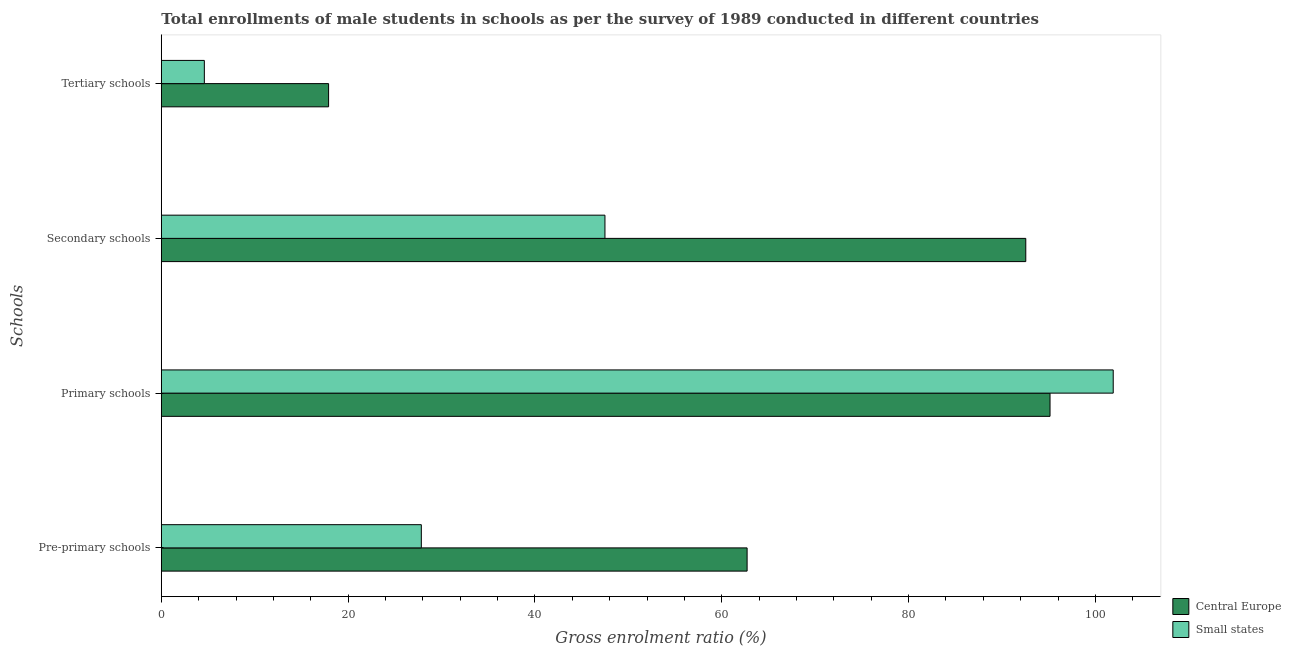How many different coloured bars are there?
Ensure brevity in your answer.  2. How many groups of bars are there?
Keep it short and to the point. 4. Are the number of bars per tick equal to the number of legend labels?
Your answer should be compact. Yes. Are the number of bars on each tick of the Y-axis equal?
Give a very brief answer. Yes. What is the label of the 2nd group of bars from the top?
Provide a short and direct response. Secondary schools. What is the gross enrolment ratio(male) in primary schools in Central Europe?
Your answer should be very brief. 95.15. Across all countries, what is the maximum gross enrolment ratio(male) in primary schools?
Provide a succinct answer. 101.91. Across all countries, what is the minimum gross enrolment ratio(male) in pre-primary schools?
Make the answer very short. 27.84. In which country was the gross enrolment ratio(male) in tertiary schools maximum?
Your response must be concise. Central Europe. In which country was the gross enrolment ratio(male) in primary schools minimum?
Provide a short and direct response. Central Europe. What is the total gross enrolment ratio(male) in pre-primary schools in the graph?
Give a very brief answer. 90.55. What is the difference between the gross enrolment ratio(male) in pre-primary schools in Small states and that in Central Europe?
Provide a short and direct response. -34.88. What is the difference between the gross enrolment ratio(male) in pre-primary schools in Small states and the gross enrolment ratio(male) in primary schools in Central Europe?
Your response must be concise. -67.31. What is the average gross enrolment ratio(male) in primary schools per country?
Keep it short and to the point. 98.53. What is the difference between the gross enrolment ratio(male) in secondary schools and gross enrolment ratio(male) in pre-primary schools in Central Europe?
Give a very brief answer. 29.84. What is the ratio of the gross enrolment ratio(male) in pre-primary schools in Central Europe to that in Small states?
Offer a very short reply. 2.25. Is the difference between the gross enrolment ratio(male) in tertiary schools in Central Europe and Small states greater than the difference between the gross enrolment ratio(male) in secondary schools in Central Europe and Small states?
Offer a terse response. No. What is the difference between the highest and the second highest gross enrolment ratio(male) in tertiary schools?
Make the answer very short. 13.3. What is the difference between the highest and the lowest gross enrolment ratio(male) in secondary schools?
Your answer should be very brief. 45.05. What does the 1st bar from the top in Primary schools represents?
Provide a short and direct response. Small states. What does the 2nd bar from the bottom in Secondary schools represents?
Give a very brief answer. Small states. Is it the case that in every country, the sum of the gross enrolment ratio(male) in pre-primary schools and gross enrolment ratio(male) in primary schools is greater than the gross enrolment ratio(male) in secondary schools?
Give a very brief answer. Yes. Are the values on the major ticks of X-axis written in scientific E-notation?
Your answer should be compact. No. Does the graph contain any zero values?
Offer a very short reply. No. Does the graph contain grids?
Provide a succinct answer. No. How many legend labels are there?
Your answer should be very brief. 2. What is the title of the graph?
Provide a short and direct response. Total enrollments of male students in schools as per the survey of 1989 conducted in different countries. What is the label or title of the Y-axis?
Offer a very short reply. Schools. What is the Gross enrolment ratio (%) of Central Europe in Pre-primary schools?
Keep it short and to the point. 62.71. What is the Gross enrolment ratio (%) in Small states in Pre-primary schools?
Provide a short and direct response. 27.84. What is the Gross enrolment ratio (%) of Central Europe in Primary schools?
Provide a succinct answer. 95.15. What is the Gross enrolment ratio (%) of Small states in Primary schools?
Your answer should be compact. 101.91. What is the Gross enrolment ratio (%) in Central Europe in Secondary schools?
Offer a terse response. 92.55. What is the Gross enrolment ratio (%) in Small states in Secondary schools?
Give a very brief answer. 47.5. What is the Gross enrolment ratio (%) of Central Europe in Tertiary schools?
Your answer should be compact. 17.91. What is the Gross enrolment ratio (%) of Small states in Tertiary schools?
Make the answer very short. 4.61. Across all Schools, what is the maximum Gross enrolment ratio (%) of Central Europe?
Provide a short and direct response. 95.15. Across all Schools, what is the maximum Gross enrolment ratio (%) in Small states?
Give a very brief answer. 101.91. Across all Schools, what is the minimum Gross enrolment ratio (%) of Central Europe?
Give a very brief answer. 17.91. Across all Schools, what is the minimum Gross enrolment ratio (%) of Small states?
Provide a succinct answer. 4.61. What is the total Gross enrolment ratio (%) of Central Europe in the graph?
Your response must be concise. 268.32. What is the total Gross enrolment ratio (%) of Small states in the graph?
Keep it short and to the point. 181.85. What is the difference between the Gross enrolment ratio (%) of Central Europe in Pre-primary schools and that in Primary schools?
Your response must be concise. -32.43. What is the difference between the Gross enrolment ratio (%) of Small states in Pre-primary schools and that in Primary schools?
Provide a succinct answer. -74.07. What is the difference between the Gross enrolment ratio (%) of Central Europe in Pre-primary schools and that in Secondary schools?
Ensure brevity in your answer.  -29.84. What is the difference between the Gross enrolment ratio (%) of Small states in Pre-primary schools and that in Secondary schools?
Give a very brief answer. -19.66. What is the difference between the Gross enrolment ratio (%) in Central Europe in Pre-primary schools and that in Tertiary schools?
Your answer should be compact. 44.81. What is the difference between the Gross enrolment ratio (%) of Small states in Pre-primary schools and that in Tertiary schools?
Your response must be concise. 23.23. What is the difference between the Gross enrolment ratio (%) of Central Europe in Primary schools and that in Secondary schools?
Offer a terse response. 2.6. What is the difference between the Gross enrolment ratio (%) in Small states in Primary schools and that in Secondary schools?
Give a very brief answer. 54.42. What is the difference between the Gross enrolment ratio (%) in Central Europe in Primary schools and that in Tertiary schools?
Your answer should be very brief. 77.24. What is the difference between the Gross enrolment ratio (%) of Small states in Primary schools and that in Tertiary schools?
Make the answer very short. 97.3. What is the difference between the Gross enrolment ratio (%) in Central Europe in Secondary schools and that in Tertiary schools?
Ensure brevity in your answer.  74.64. What is the difference between the Gross enrolment ratio (%) of Small states in Secondary schools and that in Tertiary schools?
Offer a terse response. 42.89. What is the difference between the Gross enrolment ratio (%) in Central Europe in Pre-primary schools and the Gross enrolment ratio (%) in Small states in Primary schools?
Provide a short and direct response. -39.2. What is the difference between the Gross enrolment ratio (%) of Central Europe in Pre-primary schools and the Gross enrolment ratio (%) of Small states in Secondary schools?
Provide a succinct answer. 15.22. What is the difference between the Gross enrolment ratio (%) of Central Europe in Pre-primary schools and the Gross enrolment ratio (%) of Small states in Tertiary schools?
Your answer should be very brief. 58.11. What is the difference between the Gross enrolment ratio (%) in Central Europe in Primary schools and the Gross enrolment ratio (%) in Small states in Secondary schools?
Your answer should be very brief. 47.65. What is the difference between the Gross enrolment ratio (%) of Central Europe in Primary schools and the Gross enrolment ratio (%) of Small states in Tertiary schools?
Keep it short and to the point. 90.54. What is the difference between the Gross enrolment ratio (%) of Central Europe in Secondary schools and the Gross enrolment ratio (%) of Small states in Tertiary schools?
Your answer should be compact. 87.94. What is the average Gross enrolment ratio (%) in Central Europe per Schools?
Give a very brief answer. 67.08. What is the average Gross enrolment ratio (%) in Small states per Schools?
Ensure brevity in your answer.  45.46. What is the difference between the Gross enrolment ratio (%) of Central Europe and Gross enrolment ratio (%) of Small states in Pre-primary schools?
Offer a very short reply. 34.88. What is the difference between the Gross enrolment ratio (%) of Central Europe and Gross enrolment ratio (%) of Small states in Primary schools?
Ensure brevity in your answer.  -6.76. What is the difference between the Gross enrolment ratio (%) of Central Europe and Gross enrolment ratio (%) of Small states in Secondary schools?
Offer a very short reply. 45.05. What is the difference between the Gross enrolment ratio (%) of Central Europe and Gross enrolment ratio (%) of Small states in Tertiary schools?
Your answer should be compact. 13.3. What is the ratio of the Gross enrolment ratio (%) of Central Europe in Pre-primary schools to that in Primary schools?
Offer a terse response. 0.66. What is the ratio of the Gross enrolment ratio (%) in Small states in Pre-primary schools to that in Primary schools?
Provide a short and direct response. 0.27. What is the ratio of the Gross enrolment ratio (%) in Central Europe in Pre-primary schools to that in Secondary schools?
Your response must be concise. 0.68. What is the ratio of the Gross enrolment ratio (%) of Small states in Pre-primary schools to that in Secondary schools?
Provide a succinct answer. 0.59. What is the ratio of the Gross enrolment ratio (%) of Central Europe in Pre-primary schools to that in Tertiary schools?
Your response must be concise. 3.5. What is the ratio of the Gross enrolment ratio (%) of Small states in Pre-primary schools to that in Tertiary schools?
Make the answer very short. 6.04. What is the ratio of the Gross enrolment ratio (%) in Central Europe in Primary schools to that in Secondary schools?
Keep it short and to the point. 1.03. What is the ratio of the Gross enrolment ratio (%) of Small states in Primary schools to that in Secondary schools?
Your answer should be very brief. 2.15. What is the ratio of the Gross enrolment ratio (%) of Central Europe in Primary schools to that in Tertiary schools?
Your answer should be very brief. 5.31. What is the ratio of the Gross enrolment ratio (%) in Small states in Primary schools to that in Tertiary schools?
Ensure brevity in your answer.  22.12. What is the ratio of the Gross enrolment ratio (%) in Central Europe in Secondary schools to that in Tertiary schools?
Your answer should be compact. 5.17. What is the ratio of the Gross enrolment ratio (%) in Small states in Secondary schools to that in Tertiary schools?
Your answer should be compact. 10.31. What is the difference between the highest and the second highest Gross enrolment ratio (%) of Central Europe?
Provide a short and direct response. 2.6. What is the difference between the highest and the second highest Gross enrolment ratio (%) in Small states?
Ensure brevity in your answer.  54.42. What is the difference between the highest and the lowest Gross enrolment ratio (%) in Central Europe?
Provide a succinct answer. 77.24. What is the difference between the highest and the lowest Gross enrolment ratio (%) in Small states?
Make the answer very short. 97.3. 